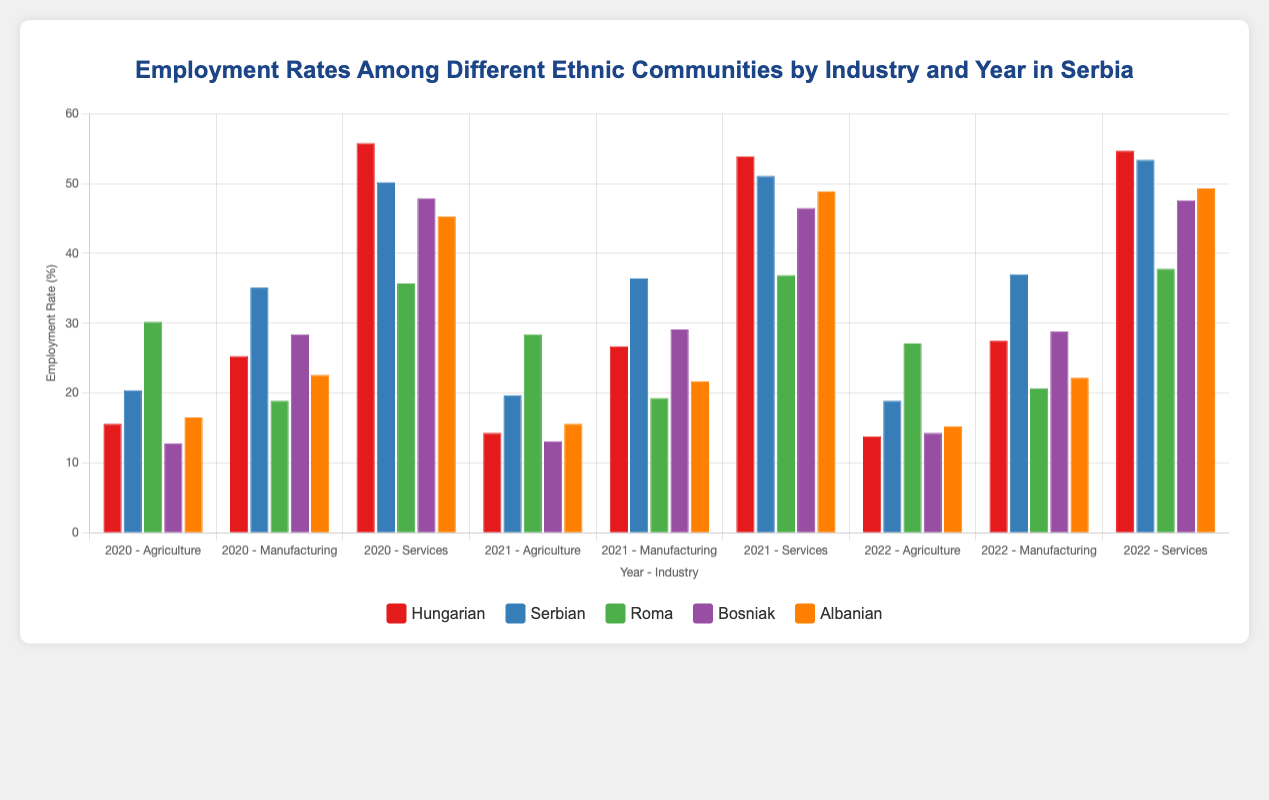What was the employment rate in Agriculture for the Hungarian community in 2022? Look at the bar for the Hungarian community in Agriculture for the year 2022.
Answer: 13.8% Which ethnic group had the highest employment rate in Services in 2021? Compare the heights of the bars for the year 2021 across all ethnic groups in the Services industry.
Answer: Albanian How did the employment rate in Manufacturing change for the Serbian community from 2020 to 2022? Check the bars for the Serbian community in Manufacturing for years 2020 and 2022 and calculate the difference.
Answer: Increased by 1.9% What is the average employment rate in Agriculture for the Roma community across the three years? Sum up the employment rates of the Roma community in Agriculture for 2020, 2021, and 2022, and divide by 3. (30.2 + 28.4 + 27.1) / 3 = 28.57
Answer: 28.57% Which industry had the highest overall employment rate for all communities combined in 2020? Add up the employment rates for all communities in each industry for the year 2020 and compare the sums. 
Agriculture: (15.6 + 20.4 + 30.2 + 12.8 + 16.5) = 95.5
Manufacturing: (25.3 + 35.1 + 18.9 + 28.4 + 22.6) = 130.3
Services: (55.8 + 50.2 + 35.7 + 47.9 + 45.3) = 234.9
Answer: Services What is the difference in employment rates between the Hungarian and Serbian communities in Manufacturing in 2021? Subtract the employment rate of the Hungarian community from the Serbian community in Manufacturing for the year 2021. 36.4 - 26.7 = 9.7
Answer: 9.7% How much did the employment rate in Services increase for the Bosniak community from 2020 to 2022? Calculate the employment rate in Services for the Bosniak community in 2020 and 2022 and find the difference. 
47.6 - 47.9 = -0.3
Answer: Decreased by 0.3% In which industry and year did the Albanian community have the lowest employment rate, and what was it? Identify the lowest bar height for the Albanian community across all industries and years.
Answer: Agriculture, 2022, 15.2% Which ethnic group had the lowest employment rate in Agriculture in 2021? Compare the bar heights in Agriculture for the year 2021 across all ethnic groups.
Answer: Bosniak 